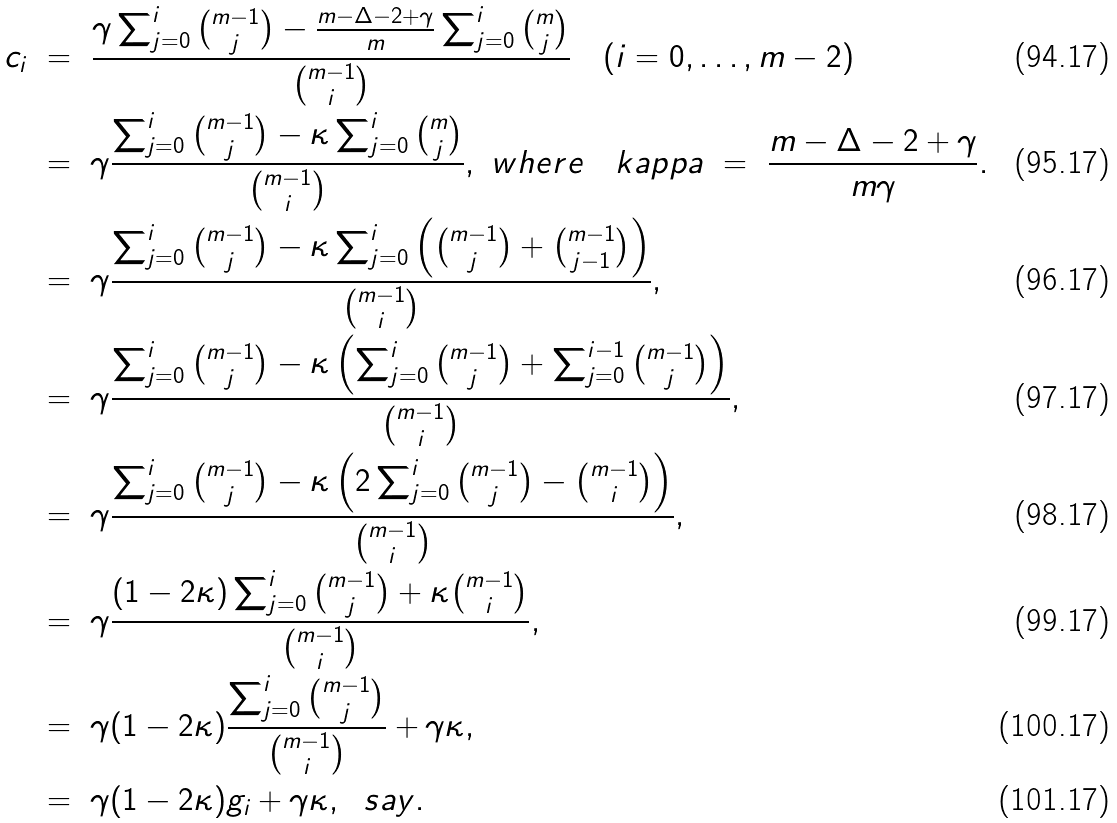Convert formula to latex. <formula><loc_0><loc_0><loc_500><loc_500>c _ { i } \ & = \ \frac { \gamma \sum _ { j = 0 } ^ { i } \binom { m - 1 } { j } - \frac { m - \Delta - 2 + \gamma } { m } \sum _ { j = 0 } ^ { i } \binom { m } { j } } { \binom { m - 1 } { i } } \quad ( i = 0 , \dots , m - 2 ) \\ & = \ \gamma \frac { \sum _ { j = 0 } ^ { i } \binom { m - 1 } { j } - \kappa \sum _ { j = 0 } ^ { i } \binom { m } { j } } { \binom { m - 1 } { i } } , \ w h e r e \quad k a p p a \ = \ \frac { m - \Delta - 2 + \gamma } { m \gamma } . \\ & = \ \gamma \frac { \sum _ { j = 0 } ^ { i } \binom { m - 1 } { j } - \kappa \sum _ { j = 0 } ^ { i } \left ( \binom { m - 1 } { j } + \binom { m - 1 } { j - 1 } \right ) } { \binom { m - 1 } { i } } , \\ & = \ \gamma \frac { \sum _ { j = 0 } ^ { i } \binom { m - 1 } { j } - \kappa \left ( \sum _ { j = 0 } ^ { i } \binom { m - 1 } { j } + \sum _ { j = 0 } ^ { i - 1 } \binom { m - 1 } { j } \right ) } { \binom { m - 1 } { i } } , \\ & = \ \gamma \frac { \sum _ { j = 0 } ^ { i } \binom { m - 1 } { j } - \kappa \left ( 2 \sum _ { j = 0 } ^ { i } \binom { m - 1 } { j } - \binom { m - 1 } { i } \right ) } { \binom { m - 1 } { i } } , \\ & = \ \gamma \frac { ( 1 - 2 \kappa ) \sum _ { j = 0 } ^ { i } \binom { m - 1 } { j } + \kappa \binom { m - 1 } { i } } { \binom { m - 1 } { i } } , \\ & = \ \gamma ( 1 - 2 \kappa ) \frac { \sum _ { j = 0 } ^ { i } \binom { m - 1 } { j } } { \binom { m - 1 } { i } } + \gamma \kappa , \\ & = \ \gamma ( 1 - 2 \kappa ) g _ { i } + \gamma \kappa , \ \ s a y .</formula> 